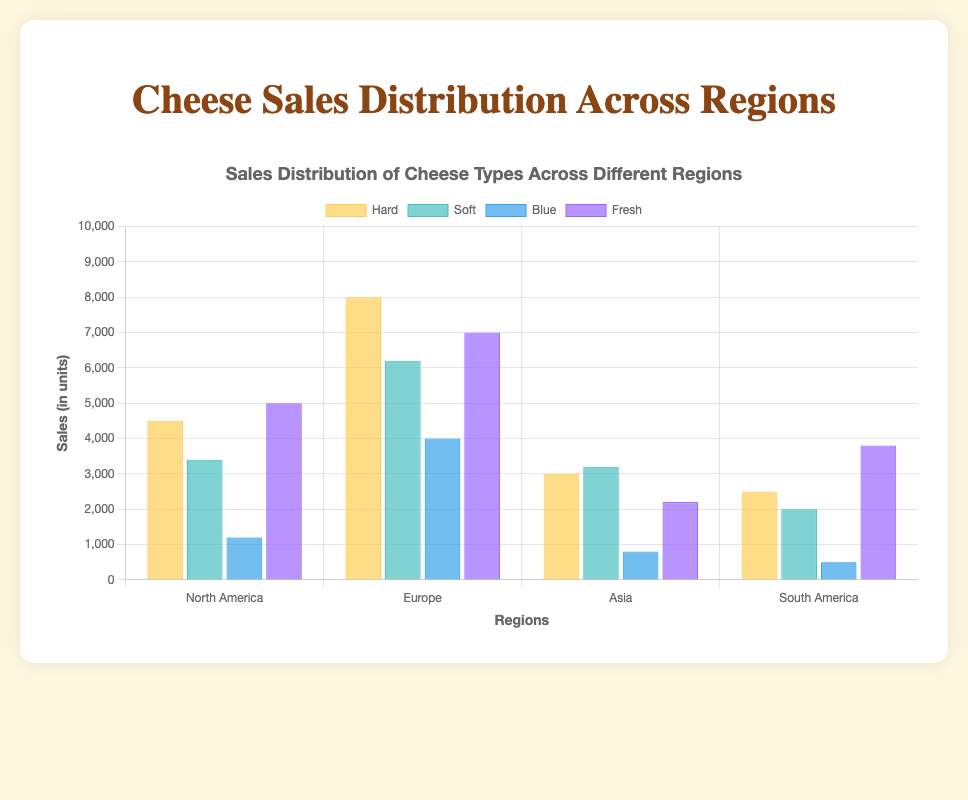Which region has the highest sales of Hard cheese? Observe the height of the bars representing Hard cheese across different regions. The bar for Europe is the highest.
Answer: Europe Which type of cheese has the lowest sales in Asia? Look at the bars in the Asia region. The bar representing Blue cheese is the shortest.
Answer: Blue What's the total sales of Soft cheese across all regions? Sum the sales of Soft cheese from each region: 3400 (North America) + 6200 (Europe) + 3200 (Asia) + 2000 (South America) = 14800
Answer: 14800 How does the sales of Blue cheese in Europe compare to its sales in South America? Compare the height of the Blue cheese bars in Europe and South America. The bar in Europe is much taller.
Answer: Higher in Europe Which cheese type has the widest distribution of sales across regions? Look for the cheese type with the most variability in bar heights across regions. Hard cheese shows a wide range from 2500 to 8000.
Answer: Hard Are the sales of Fresh cheese higher in North America or Asia? Compare the height of the Fresh cheese bars in North America and Asia. The bar in North America is taller.
Answer: North America What's the difference in sales of Hard cheese between North America and South America? Subtract the sales of Hard cheese in South America from North America: 4500 - 2500 = 2000
Answer: 2000 Which region has the most balanced sales distribution across all four cheese types? Look for the region where the bars for all cheese types are closest in height. Asia has relatively even heights for different cheese types.
Answer: Asia Identify the type and region with the highest single sales figure. Look for the tallest bar in the entire chart. The Fresh cheese bar in North America is the tallest at 5000 units.
Answer: Fresh in North America What is the average sales of Blue cheese across all regions? Calculate the average by summing the sales and dividing by the number of regions: (1200 + 4000 + 800 + 500) / 4 = 1625
Answer: 1625 